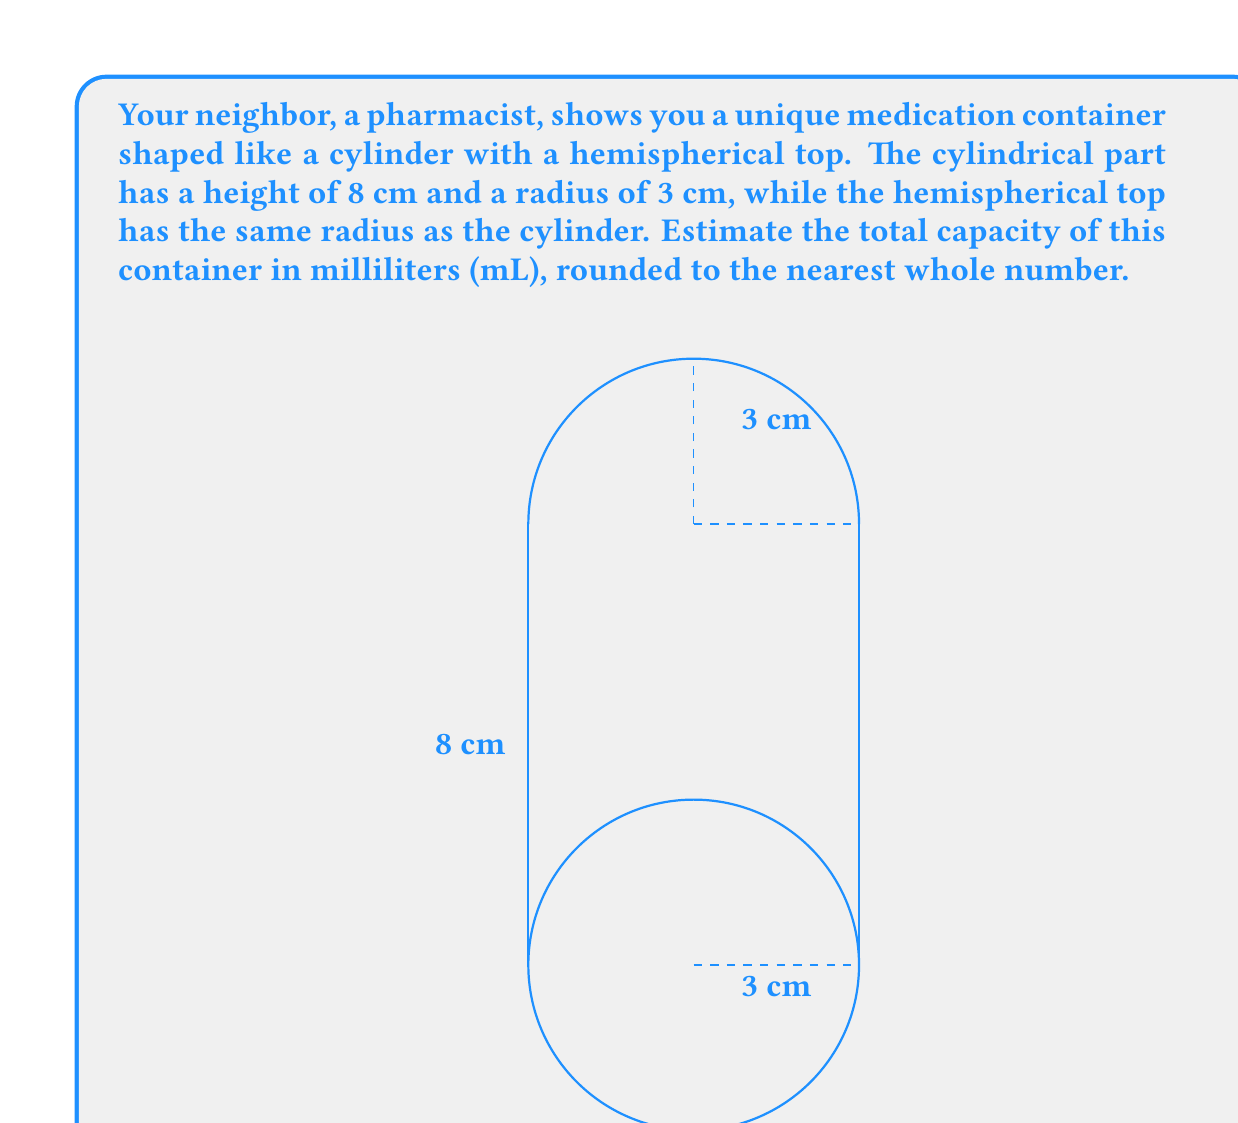What is the answer to this math problem? Let's break this problem down into steps:

1) The container consists of two parts: a cylinder and a hemisphere. We need to calculate the volume of each part and then sum them up.

2) For the cylinder:
   Volume of cylinder = $\pi r^2 h$
   where $r$ is the radius and $h$ is the height.
   $V_{cylinder} = \pi (3\text{ cm})^2 (8\text{ cm}) = 72\pi\text{ cm}^3$

3) For the hemisphere:
   Volume of hemisphere = $\frac{2}{3}\pi r^3$
   where $r$ is the radius.
   $V_{hemisphere} = \frac{2}{3}\pi (3\text{ cm})^3 = 18\pi\text{ cm}^3$

4) Total volume:
   $V_{total} = V_{cylinder} + V_{hemisphere} = 72\pi\text{ cm}^3 + 18\pi\text{ cm}^3 = 90\pi\text{ cm}^3$

5) Convert $\text{cm}^3$ to mL:
   $1\text{ cm}^3 = 1\text{ mL}$, so no conversion is needed.

6) Calculate the final value:
   $V_{total} = 90\pi\text{ mL} \approx 282.7433\text{ mL}$

7) Rounding to the nearest whole number:
   $V_{total} \approx 283\text{ mL}$
Answer: 283 mL 